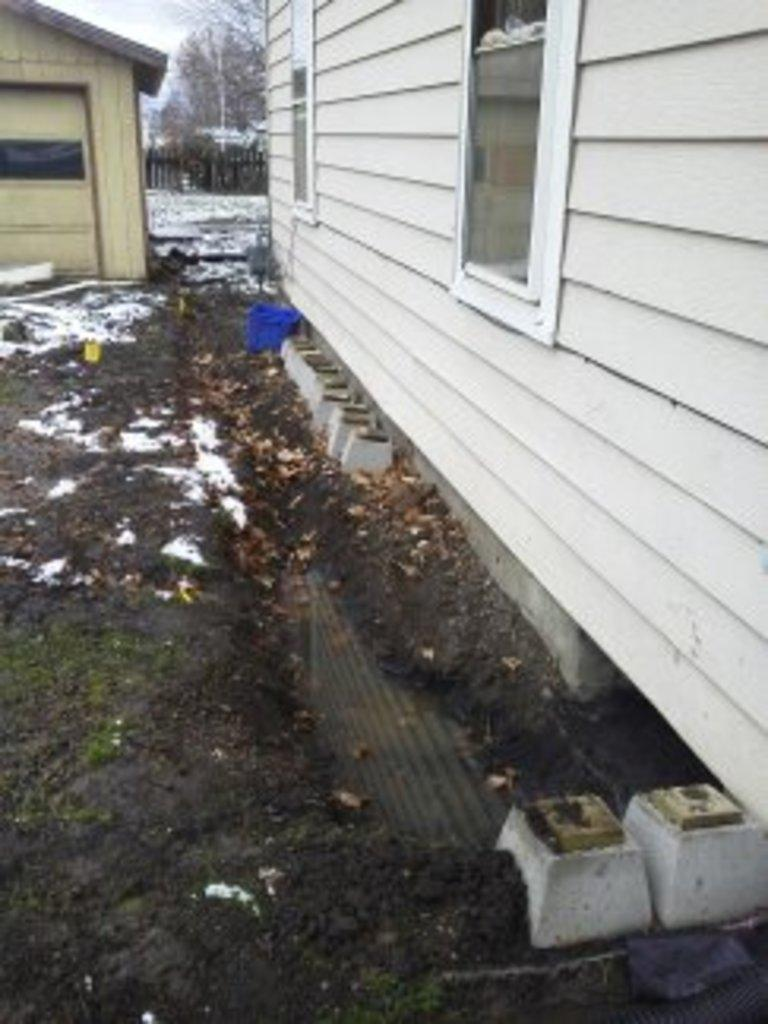What type of structures can be seen in the image? There are houses in the image. What feature is present in the houses? There are windows in the image. What type of terrain is visible in the image? There is mud and snow in the image. What can be seen in the background of the image? There are trees and a fence in the background of the image. How many feet are visible in the image? There are no feet visible in the image. What type of animal can be seen interacting with the houses in the image? There are no animals present in the image; it only features houses, windows, mud, snow, trees, and a fence. 